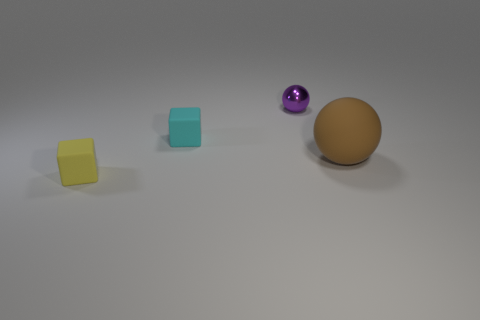Subtract 1 cubes. How many cubes are left? 1 Subtract all red spheres. Subtract all gray cubes. How many spheres are left? 2 Subtract all purple balls. How many cyan blocks are left? 1 Subtract all purple metal spheres. Subtract all tiny yellow rubber blocks. How many objects are left? 2 Add 2 purple metallic things. How many purple metallic things are left? 3 Add 3 gray spheres. How many gray spheres exist? 3 Add 3 small gray metallic objects. How many objects exist? 7 Subtract 0 gray cylinders. How many objects are left? 4 